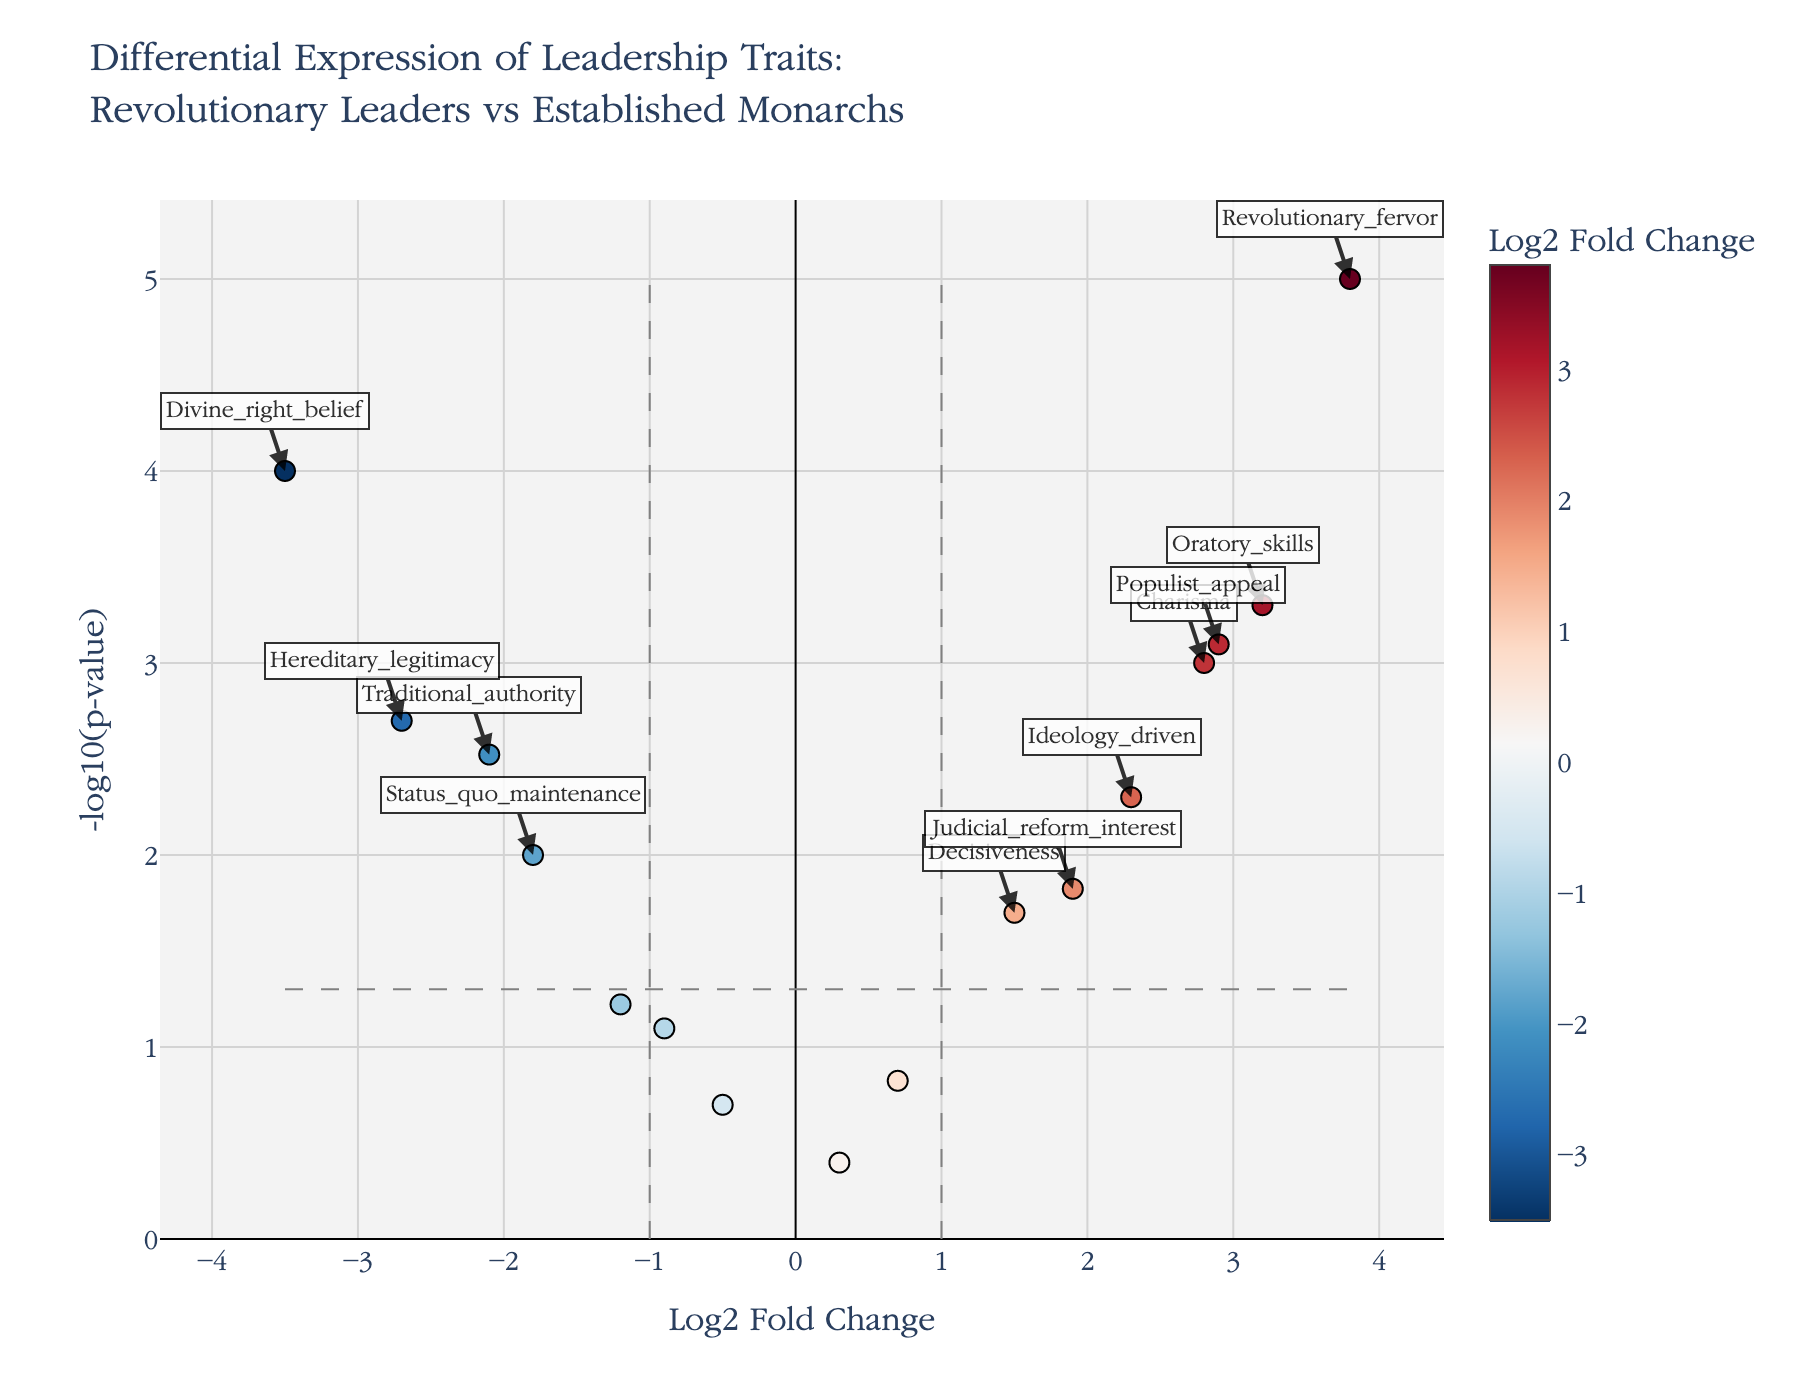What does the title of the figure indicate? The title of the figure reads "Differential Expression of Leadership Traits: Revolutionary Leaders vs Established Monarchs," which indicates that the plot compares the expression levels of different leadership traits between revolutionary leaders and established monarchs.
Answer: Differential Expression of Leadership Traits: Revolutionary Leaders vs Established Monarchs What do the X and Y axes represent in the plot? The X-axis represents the log2 fold change in the expression of leadership traits, while the Y-axis represents the negative logarithm of the p-value (-log10(p-value)). These axes help in identifying significant changes in leadership traits.
Answer: X-axis: Log2 Fold Change, Y-axis: -log10(p-value) How many data points are labeled with their gene names? Data points are labeled with their gene names if they exceed both the fold change threshold (absolute value > 1) and the p-value threshold (< 0.05). Counting the labeled points, there are seven: Charisma, Oratory_skills, Traditional_authority, Divine_right_belief, Populist_appeal, Hereditary_legitimacy, and Revolutionary_fervor.
Answer: 7 Which trait has the highest log2 fold change among the revolutionary leaders? Traits positioned farthest to the right on the X-axis possess the highest log2 fold change. Revolutionary_fervor has the highest value, indicating it is most significantly expressed among revolutionary leaders.
Answer: Revolutionary_fervor What is the log2 fold change and p-value for the trait "Divine_right_belief"? From the hover text information and labeled points, the log2 fold change for Divine_right_belief is -3.5, and the p-value is 0.0001.
Answer: Log2 Fold Change: -3.5, P-value: 0.0001 Which leadership trait has the highest statistical significance? The highest statistical significance corresponds to the highest -log10(p-value). Revolutionary_fervor has the highest -log10(p-value), making it the most statistically significant trait.
Answer: Revolutionary_fervor Which leadership traits show a negative log2 fold change and are statistically significant? Traits with a negative log2 fold change on the left side of the X-axis and below the p-value threshold of 0.05 meet the criteria. These traits are Traditional_authority, Divine_right_belief, and Hereditary_legitimacy.
Answer: Traditional_authority, Divine_right_belief, Hereditary_legitimacy Compare the expression of Charisma and Hereditary_legitimacy. Charisma has a positive log2 fold change, indicating it is more expressed in revolutionary leaders, while Hereditary_legitimacy has a negative log2 fold change, showing higher expression in established monarchs. Both are statistically significant traits.
Answer: Charisma is higher in revolutionary leaders; Hereditary_legitimacy is higher in established monarchs Which traits fall within the significance thresholds outlined by the dashed lines? Traits falling within both log2 fold change thresholds of -1 to 1 and p-value threshold of 0.05 (horizontal line) are Decisiveness, Adaptability, Military_strategy, Diplomatic_finesse, Constitutional_respect, and Autocratic_tendency.
Answer: Decisiveness, Adaptability, Military_strategy, Diplomatic_finesse, Constitutional_respect, Autocratic_tendency 